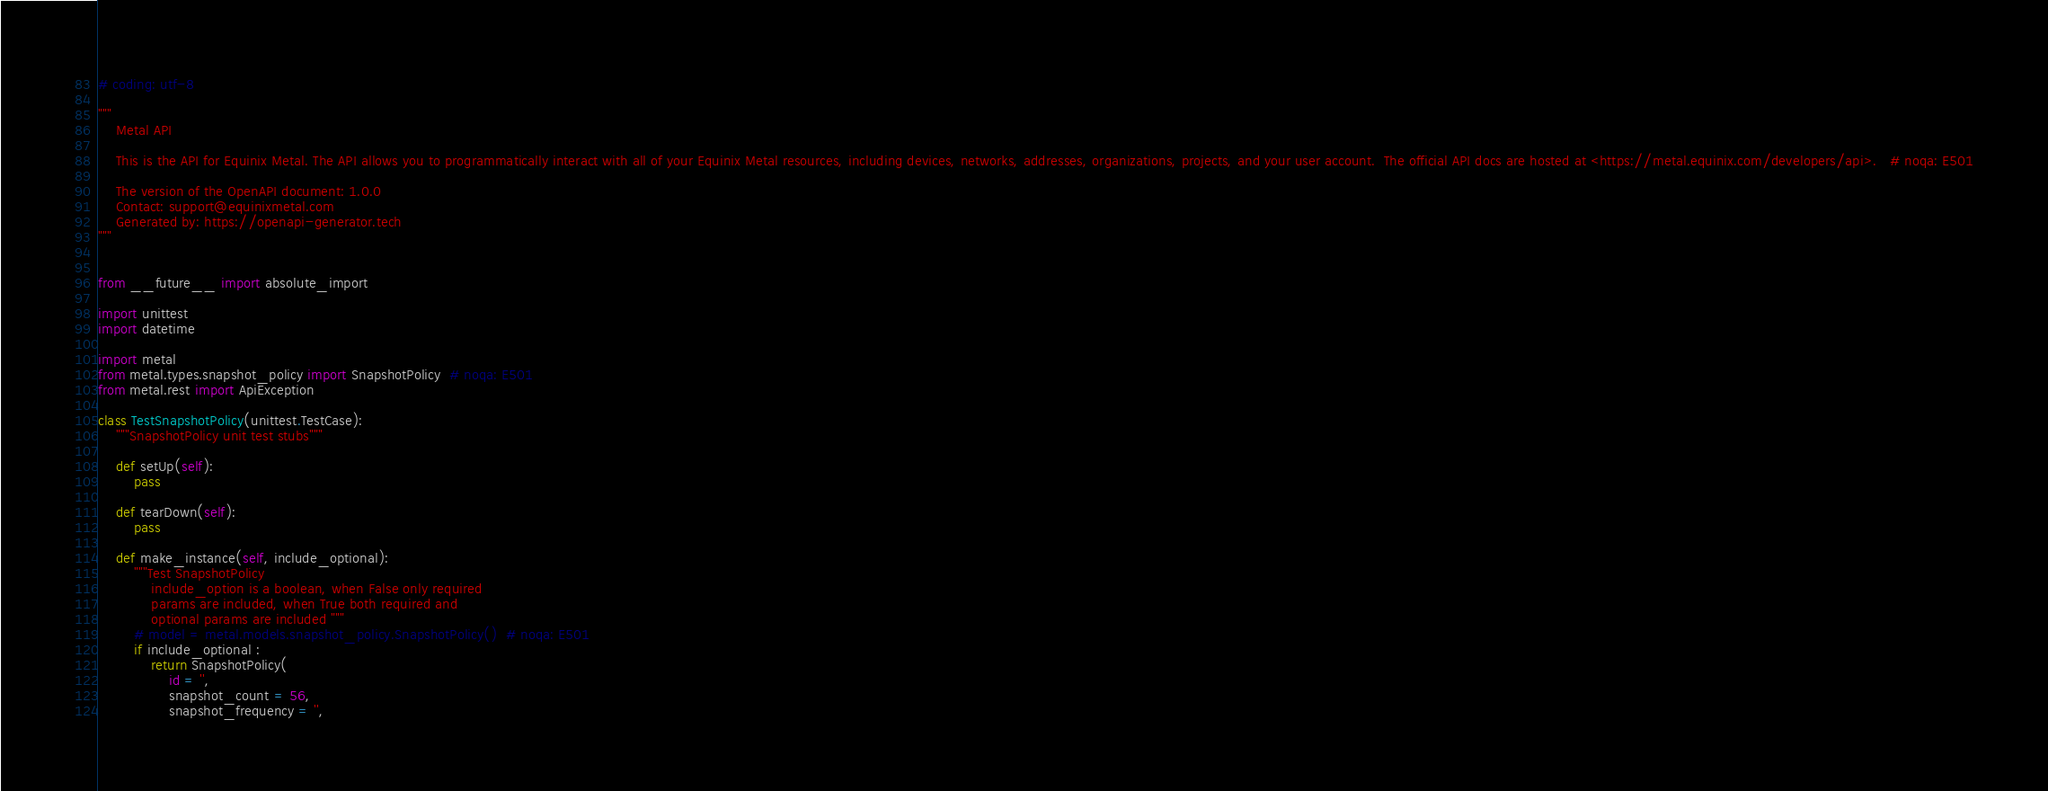<code> <loc_0><loc_0><loc_500><loc_500><_Python_># coding: utf-8

"""
    Metal API

    This is the API for Equinix Metal. The API allows you to programmatically interact with all of your Equinix Metal resources, including devices, networks, addresses, organizations, projects, and your user account.  The official API docs are hosted at <https://metal.equinix.com/developers/api>.   # noqa: E501

    The version of the OpenAPI document: 1.0.0
    Contact: support@equinixmetal.com
    Generated by: https://openapi-generator.tech
"""


from __future__ import absolute_import

import unittest
import datetime

import metal
from metal.types.snapshot_policy import SnapshotPolicy  # noqa: E501
from metal.rest import ApiException

class TestSnapshotPolicy(unittest.TestCase):
    """SnapshotPolicy unit test stubs"""

    def setUp(self):
        pass

    def tearDown(self):
        pass

    def make_instance(self, include_optional):
        """Test SnapshotPolicy
            include_option is a boolean, when False only required
            params are included, when True both required and
            optional params are included """
        # model = metal.models.snapshot_policy.SnapshotPolicy()  # noqa: E501
        if include_optional :
            return SnapshotPolicy(
                id = '', 
                snapshot_count = 56, 
                snapshot_frequency = '', </code> 